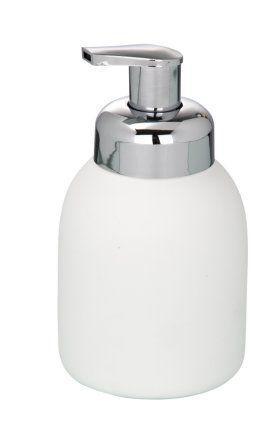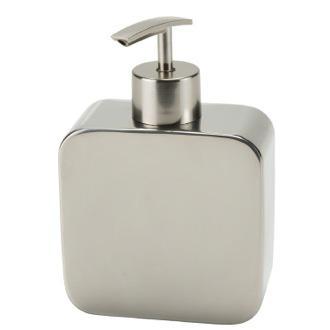The first image is the image on the left, the second image is the image on the right. Assess this claim about the two images: "The pump on the left is not connected to a container.". Correct or not? Answer yes or no. No. The first image is the image on the left, the second image is the image on the right. Examine the images to the left and right. Is the description "There is a silver colored dispenser in the right image." accurate? Answer yes or no. Yes. 